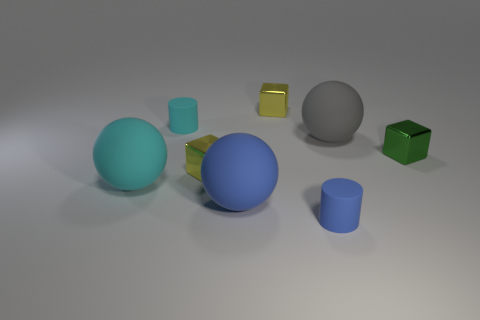Is the small block that is behind the tiny cyan cylinder made of the same material as the tiny yellow thing that is in front of the gray matte sphere?
Keep it short and to the point. Yes. What shape is the cyan matte thing that is the same size as the green metal block?
Your answer should be compact. Cylinder. There is a rubber thing that is on the left side of the small cyan rubber cylinder; is there a cyan thing left of it?
Your answer should be very brief. No. Is there a small green metallic block behind the yellow cube to the right of the small yellow metal block on the left side of the large blue thing?
Provide a succinct answer. No. Is the shape of the tiny yellow thing that is behind the tiny green metallic object the same as the large blue matte object that is in front of the big gray object?
Make the answer very short. No. There is another tiny cylinder that is the same material as the blue cylinder; what is its color?
Provide a succinct answer. Cyan. Is the number of large things that are in front of the gray ball less than the number of small brown rubber objects?
Provide a short and direct response. No. How big is the cube on the right side of the big rubber ball that is behind the green object that is in front of the gray object?
Your answer should be compact. Small. Is the cube on the right side of the blue matte cylinder made of the same material as the blue ball?
Offer a terse response. No. Is there anything else that has the same shape as the big blue thing?
Provide a succinct answer. Yes. 